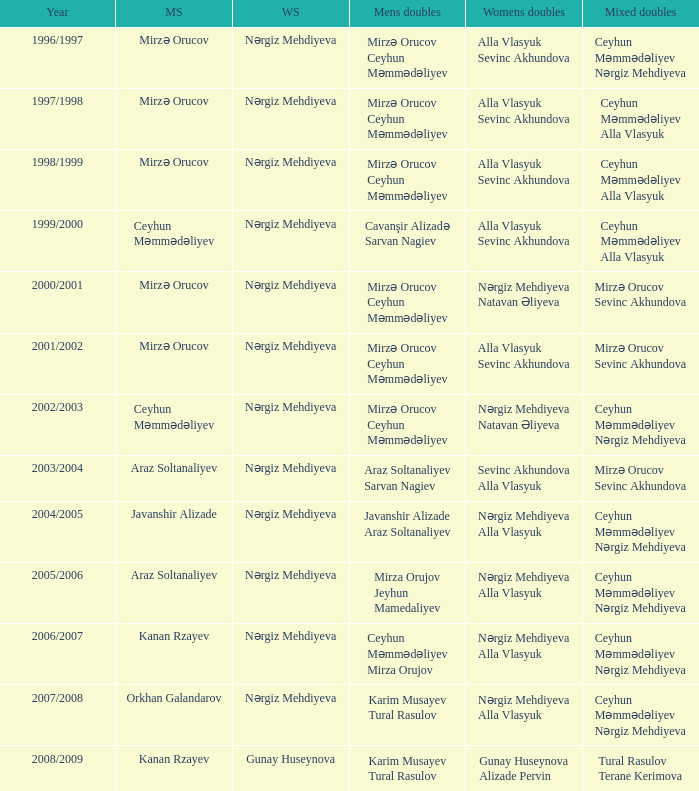I'm looking to parse the entire table for insights. Could you assist me with that? {'header': ['Year', 'MS', 'WS', 'Mens doubles', 'Womens doubles', 'Mixed doubles'], 'rows': [['1996/1997', 'Mirzə Orucov', 'Nərgiz Mehdiyeva', 'Mirzə Orucov Ceyhun Məmmədəliyev', 'Alla Vlasyuk Sevinc Akhundova', 'Ceyhun Məmmədəliyev Nərgiz Mehdiyeva'], ['1997/1998', 'Mirzə Orucov', 'Nərgiz Mehdiyeva', 'Mirzə Orucov Ceyhun Məmmədəliyev', 'Alla Vlasyuk Sevinc Akhundova', 'Ceyhun Məmmədəliyev Alla Vlasyuk'], ['1998/1999', 'Mirzə Orucov', 'Nərgiz Mehdiyeva', 'Mirzə Orucov Ceyhun Məmmədəliyev', 'Alla Vlasyuk Sevinc Akhundova', 'Ceyhun Məmmədəliyev Alla Vlasyuk'], ['1999/2000', 'Ceyhun Məmmədəliyev', 'Nərgiz Mehdiyeva', 'Cavanşir Alizadə Sarvan Nagiev', 'Alla Vlasyuk Sevinc Akhundova', 'Ceyhun Məmmədəliyev Alla Vlasyuk'], ['2000/2001', 'Mirzə Orucov', 'Nərgiz Mehdiyeva', 'Mirzə Orucov Ceyhun Məmmədəliyev', 'Nərgiz Mehdiyeva Natavan Əliyeva', 'Mirzə Orucov Sevinc Akhundova'], ['2001/2002', 'Mirzə Orucov', 'Nərgiz Mehdiyeva', 'Mirzə Orucov Ceyhun Məmmədəliyev', 'Alla Vlasyuk Sevinc Akhundova', 'Mirzə Orucov Sevinc Akhundova'], ['2002/2003', 'Ceyhun Məmmədəliyev', 'Nərgiz Mehdiyeva', 'Mirzə Orucov Ceyhun Məmmədəliyev', 'Nərgiz Mehdiyeva Natavan Əliyeva', 'Ceyhun Məmmədəliyev Nərgiz Mehdiyeva'], ['2003/2004', 'Araz Soltanaliyev', 'Nərgiz Mehdiyeva', 'Araz Soltanaliyev Sarvan Nagiev', 'Sevinc Akhundova Alla Vlasyuk', 'Mirzə Orucov Sevinc Akhundova'], ['2004/2005', 'Javanshir Alizade', 'Nərgiz Mehdiyeva', 'Javanshir Alizade Araz Soltanaliyev', 'Nərgiz Mehdiyeva Alla Vlasyuk', 'Ceyhun Məmmədəliyev Nərgiz Mehdiyeva'], ['2005/2006', 'Araz Soltanaliyev', 'Nərgiz Mehdiyeva', 'Mirza Orujov Jeyhun Mamedaliyev', 'Nərgiz Mehdiyeva Alla Vlasyuk', 'Ceyhun Məmmədəliyev Nərgiz Mehdiyeva'], ['2006/2007', 'Kanan Rzayev', 'Nərgiz Mehdiyeva', 'Ceyhun Məmmədəliyev Mirza Orujov', 'Nərgiz Mehdiyeva Alla Vlasyuk', 'Ceyhun Məmmədəliyev Nərgiz Mehdiyeva'], ['2007/2008', 'Orkhan Galandarov', 'Nərgiz Mehdiyeva', 'Karim Musayev Tural Rasulov', 'Nərgiz Mehdiyeva Alla Vlasyuk', 'Ceyhun Məmmədəliyev Nərgiz Mehdiyeva'], ['2008/2009', 'Kanan Rzayev', 'Gunay Huseynova', 'Karim Musayev Tural Rasulov', 'Gunay Huseynova Alizade Pervin', 'Tural Rasulov Terane Kerimova']]} Who were all womens doubles for the year 2000/2001? Nərgiz Mehdiyeva Natavan Əliyeva. 